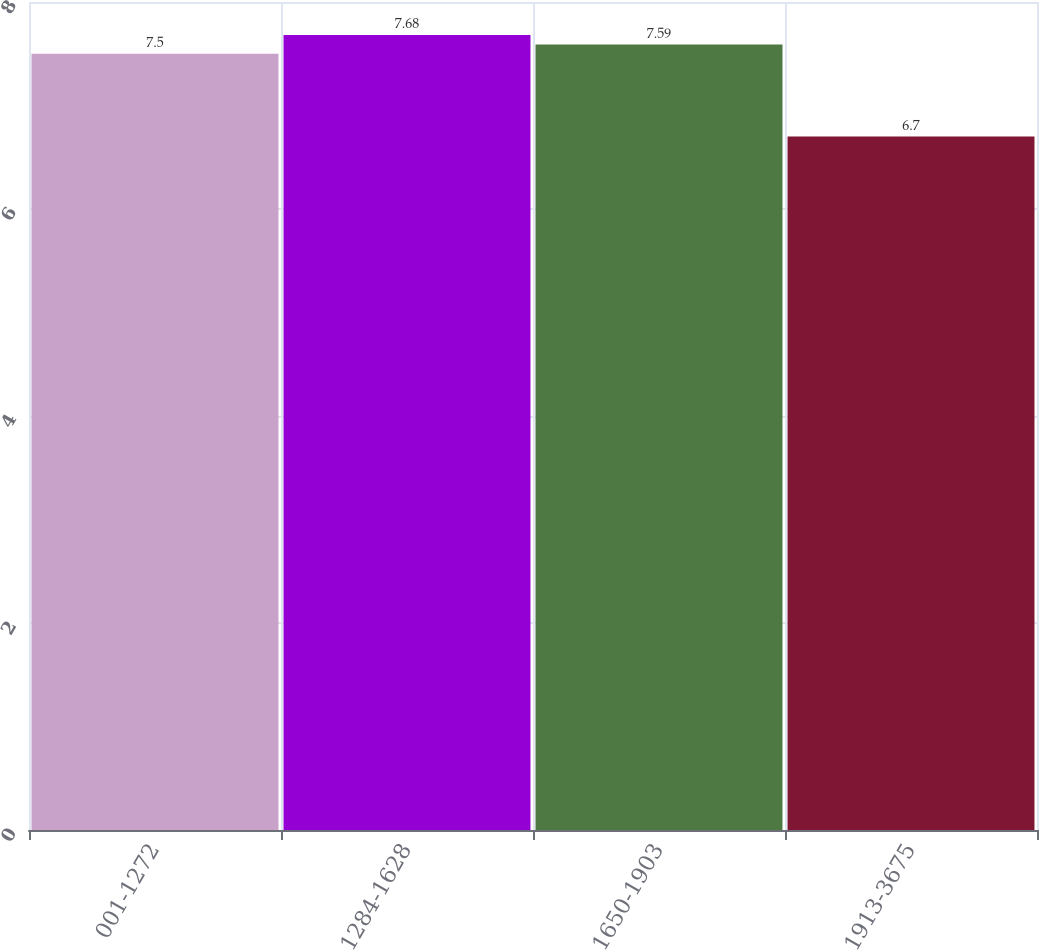Convert chart. <chart><loc_0><loc_0><loc_500><loc_500><bar_chart><fcel>001-1272<fcel>1284-1628<fcel>1650-1903<fcel>1913-3675<nl><fcel>7.5<fcel>7.68<fcel>7.59<fcel>6.7<nl></chart> 